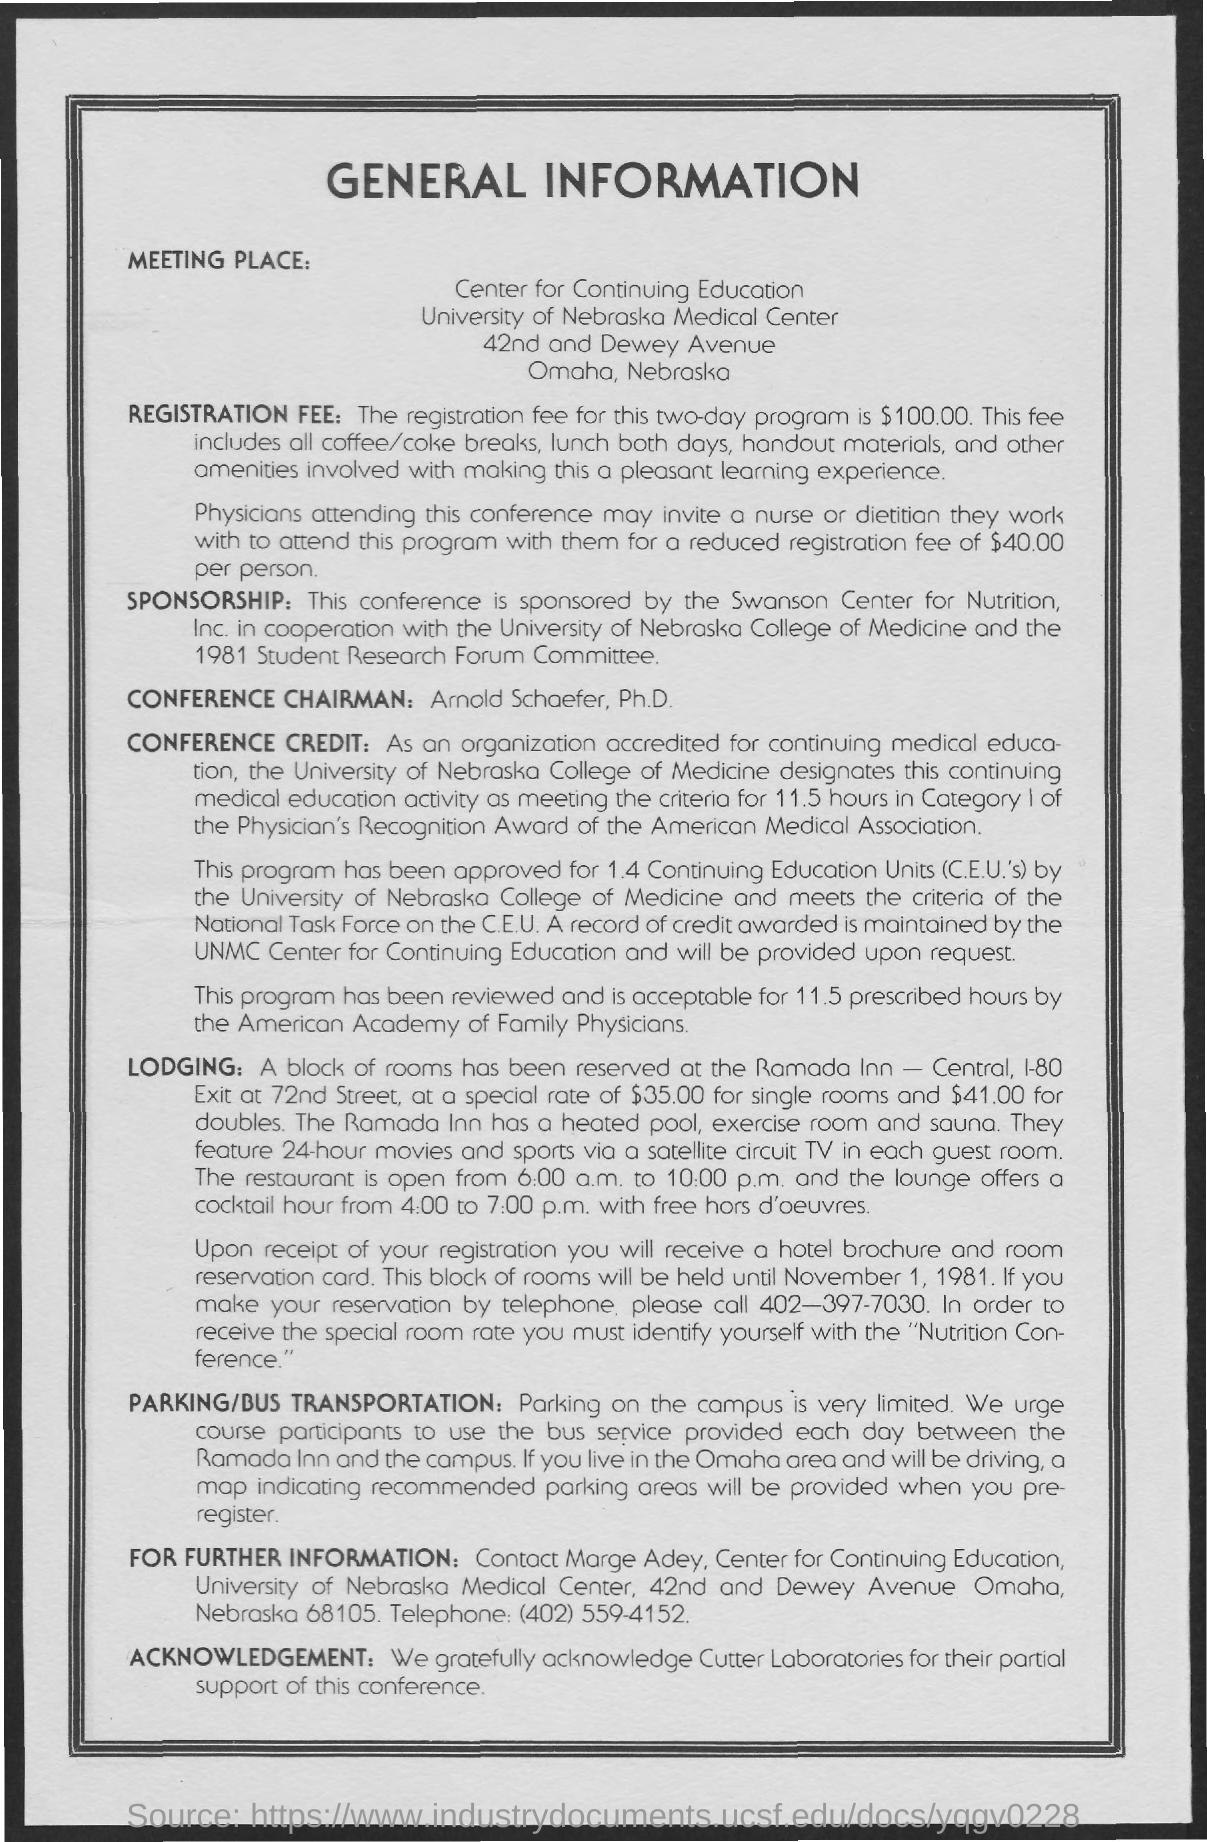Who is the conference chairman ?
Provide a succinct answer. Arnold Schaefer , ph.D. How much is the registration fee for the two days program
Offer a very short reply. $100.00. In which state and city  meeting took place
Your answer should be compact. Omaha , nebraska. What is the special rate for single rooms?
Give a very brief answer. $35.00. What is the special rate for doubles ?
Make the answer very short. $41.00. To make a reservation by telephone what is the contact number ?
Offer a very short reply. 402-397-7030. 